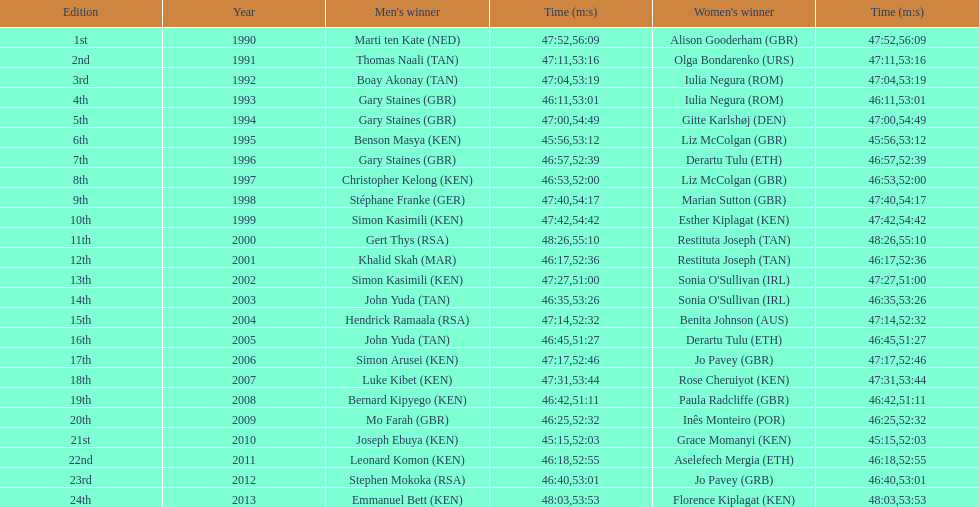Were there any instances where a woman was faster than a man? No. 